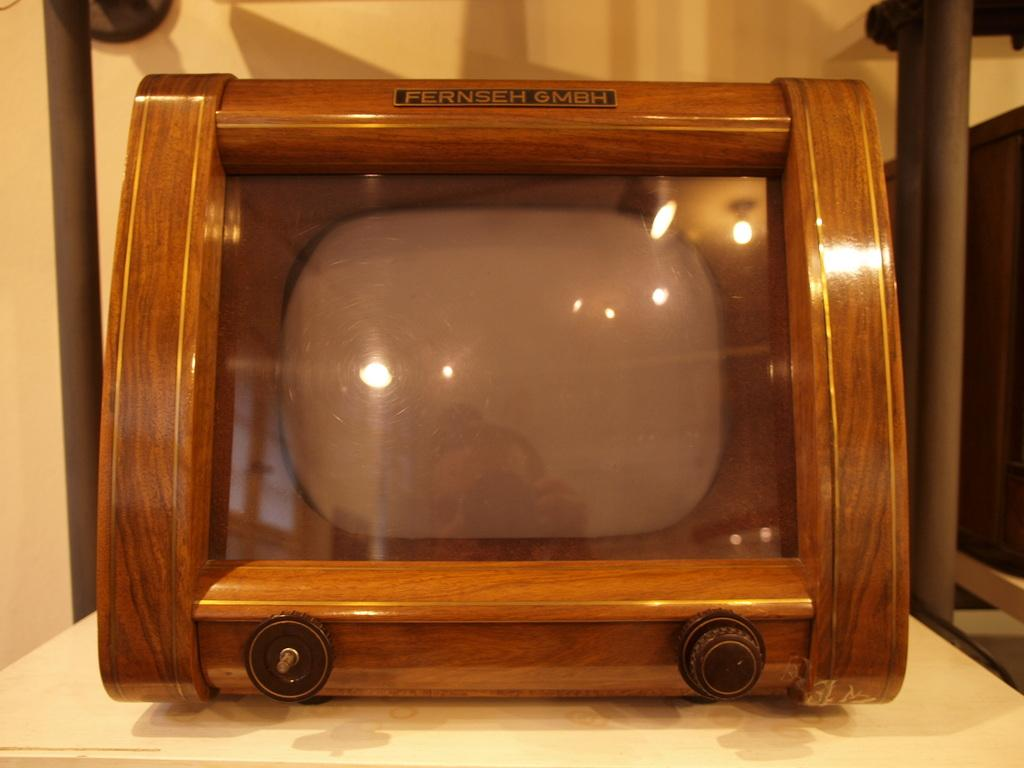Provide a one-sentence caption for the provided image. The table has an old fashioned Fernseh GMBH television set. 